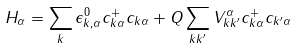<formula> <loc_0><loc_0><loc_500><loc_500>H _ { \alpha } = \sum _ { k } \epsilon ^ { 0 } _ { k , \alpha } c ^ { + } _ { k \alpha } c _ { k \alpha } + Q \sum _ { k k ^ { \prime } } V ^ { \alpha } _ { k k ^ { \prime } } c ^ { + } _ { k \alpha } c _ { k ^ { \prime } \alpha }</formula> 